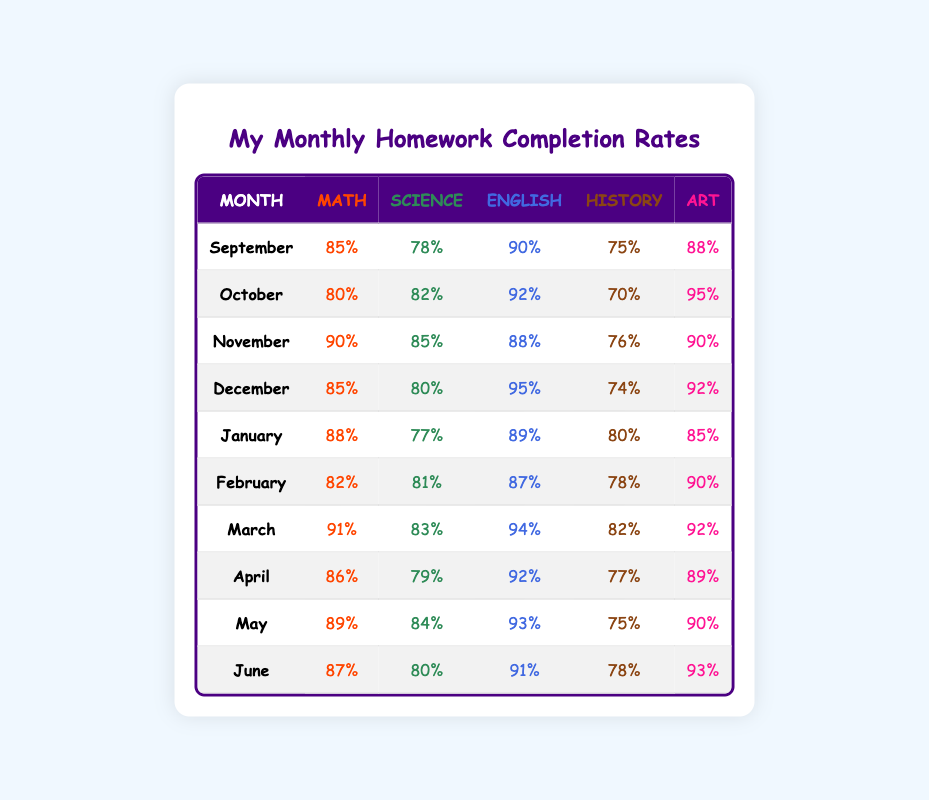What was the highest homework completion rate in Math? Looking at the Math column, the highest value is 91% in March.
Answer: 91% Which month had the lowest homework completion rate in History? In the History column, the lowest value is 70%, which occurs in October.
Answer: 70% What is the average homework completion rate for Science over the six months? To find the average for Science, sum the values (78 + 82 + 85 + 80 + 77 + 81 + 83 + 79 + 84 + 80) = 805, and divide by 10 which gives 805/10 = 80.5%.
Answer: 80.5% Did English have a completion rate above 90% in any month? Yes, in September (90%), October (92%), December (95%), and March (94%), the completion rates for English were above 90%.
Answer: Yes Which subject had the highest completion rate in April? Looking at April's row, English has the highest completion rate at 92%.
Answer: 92% What was the total homework completion rate for Art across all months? The completion rates for Art are: 88%, 95%, 90%, 92%, 85%, 90%, 92%, 89%, 90%, 93%. Adding these together gives 889%. Dividing by 10 for the average gives 89%.
Answer: 89% In which month did Science have the highest completion rate, and what was it? The highest completion rate for Science is 85%, which occurred in November.
Answer: November, 85% If we compare October and January for completion rates in English, which month was better? In October, the completion rate was 92%, while in January it was 89%. Thus, October was better for English completion.
Answer: October What is the difference between the highest and lowest completion rates in Math? The highest completion rate in Math is 91% (March) and the lowest is 80% (October). The difference is 91% - 80% = 11%.
Answer: 11% Are there any months where all subjects had completion rates above 85%? Yes, in March, all subjects had completion rates above 85%.
Answer: Yes 